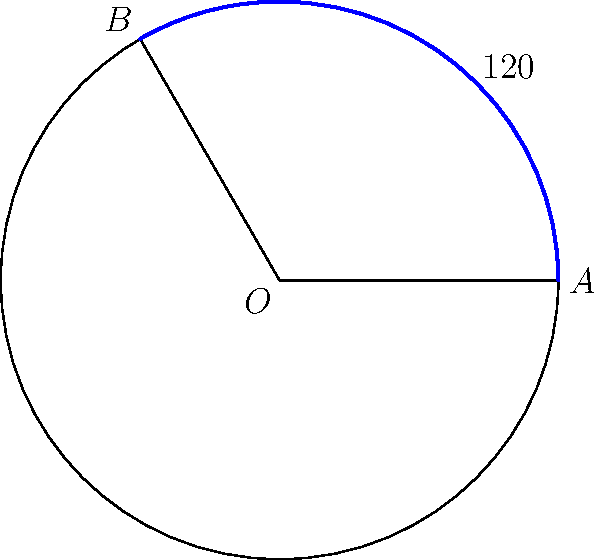At Palmerston Park, home of Queen of the South FC, a new circular VIP seating area is being designed. The circular section has a radius of 15 meters, and the VIP area covers an angle of 120°. What is the area of this VIP seating section in square meters? (Use π = 3.14) Let's approach this step-by-step:

1) The area of a circular sector is given by the formula:
   
   $$A = \frac{\theta}{360°} \cdot \pi r^2$$

   Where $\theta$ is the central angle in degrees, and $r$ is the radius.

2) We're given:
   - Radius $r = 15$ meters
   - Central angle $\theta = 120°$
   - $\pi = 3.14$

3) Let's substitute these values into our formula:

   $$A = \frac{120°}{360°} \cdot 3.14 \cdot 15^2$$

4) Simplify:
   
   $$A = \frac{1}{3} \cdot 3.14 \cdot 225$$

5) Calculate:
   
   $$A = 235.5 \text{ m}^2$$

Therefore, the area of the VIP seating section is 235.5 square meters.
Answer: 235.5 m² 